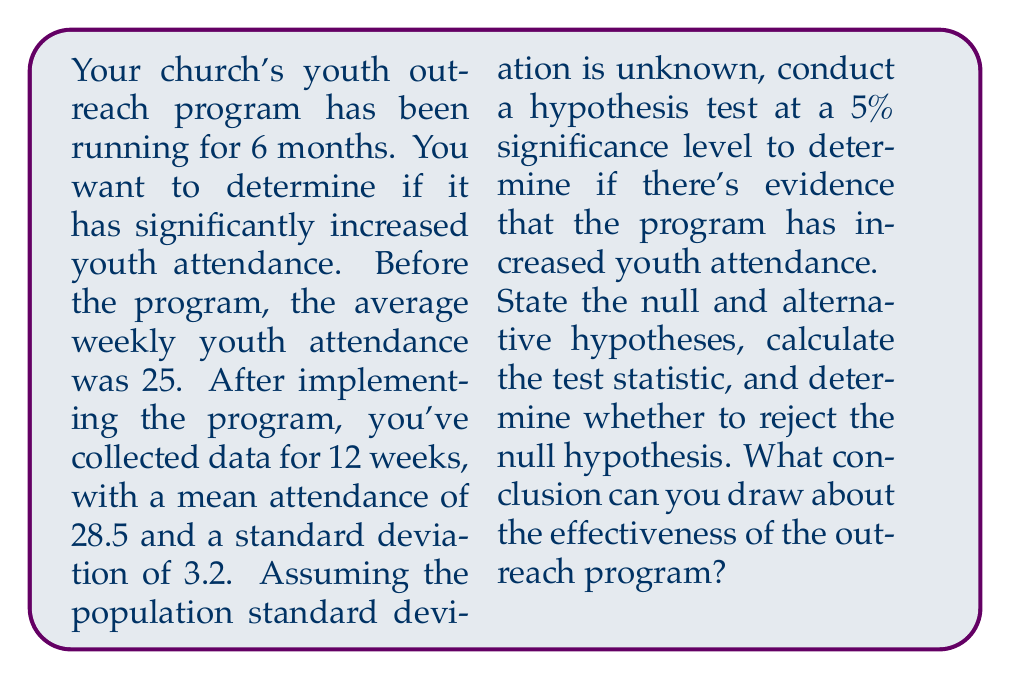Teach me how to tackle this problem. Let's approach this step-by-step:

1) First, we need to set up our hypotheses:
   $H_0: \mu \leq 25$ (null hypothesis)
   $H_a: \mu > 25$ (alternative hypothesis)
   Where $\mu$ is the true mean attendance after implementing the program.

2) We're using a one-tailed t-test because we're only interested in an increase in attendance and we don't know the population standard deviation.

3) Given information:
   - Sample size, $n = 12$
   - Sample mean, $\bar{x} = 28.5$
   - Sample standard deviation, $s = 3.2$
   - Significance level, $\alpha = 0.05$
   - Degrees of freedom, $df = n - 1 = 11$

4) Calculate the t-statistic:
   $$t = \frac{\bar{x} - \mu_0}{s/\sqrt{n}} = \frac{28.5 - 25}{3.2/\sqrt{12}} = 3.798$$

5) Find the critical t-value:
   For a one-tailed test with $\alpha = 0.05$ and $df = 11$, the critical t-value is approximately 1.796.

6) Decision rule:
   Reject $H_0$ if $t > 1.796$

7) Since our calculated t-statistic (3.798) is greater than the critical value (1.796), we reject the null hypothesis.

8) Conclusion:
   There is sufficient evidence to conclude that the youth outreach program has significantly increased youth attendance at the 5% significance level.
Answer: Reject $H_0$; evidence supports increased attendance due to outreach program. 